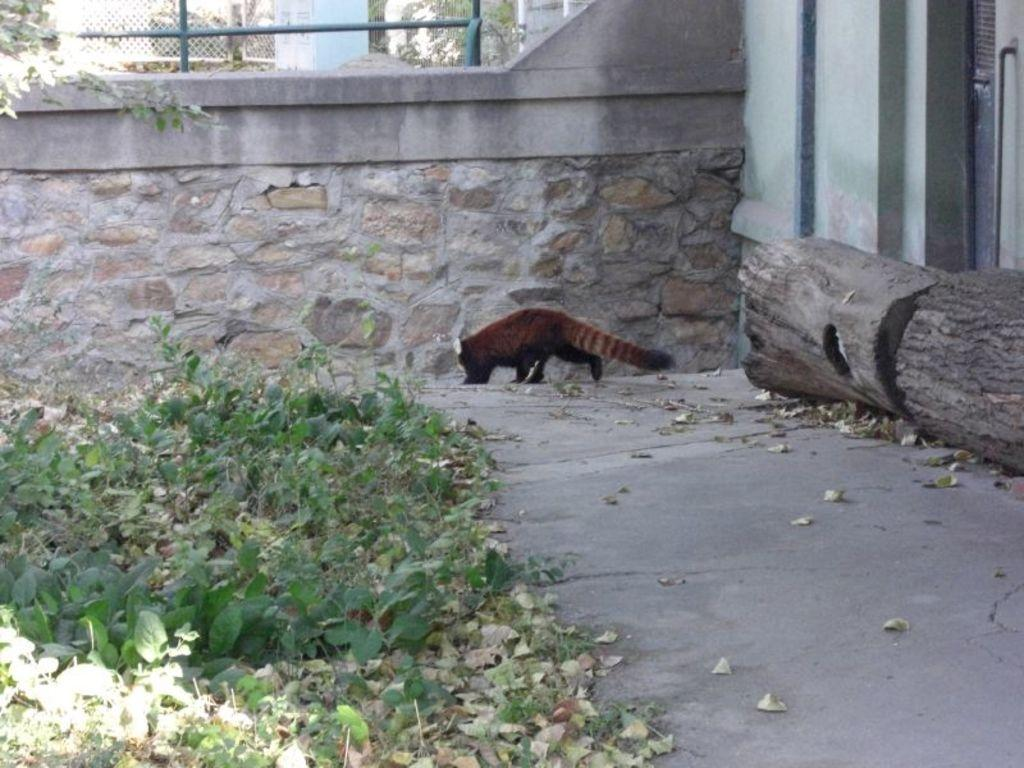What type of animal can be seen on the ground in the image? There is an animal present on the ground in the image, but the specific type cannot be determined from the facts provided. What kind of vegetation is visible in the image? There are plants in the image. What can be found on the ground along with the plants? Dried leaves are visible in the image. What other objects can be seen on the ground? There is a wooden log in the image. Are there any man-made structures visible in the image? Yes, poles, a fence, and a wall are present in the image. Reasoning: Let's think step by step by step in order to produce the conversation. We start by identifying the main subjects and objects in the image based on the provided facts. We then formulate questions that focus on the location and characteristics of these subjects and objects, ensuring that each question can be answered definitively with the information given. We avoid yes/no questions and ensure that the language is simple and clear. Absurd Question/Answer: What type of engine is powering the animal in the image? There is no engine present in the image, and the animal is not depicted as being powered by any machinery. Can you see the animal's nose in the image? The specific type of animal cannot be determined from the facts provided, so it is impossible to say whether its nose is visible or not. What type of fan is being used to cool down the wooden log in the image? There is no fan present in the image, and the wooden log is not depicted as being cooled down by any machinery. 